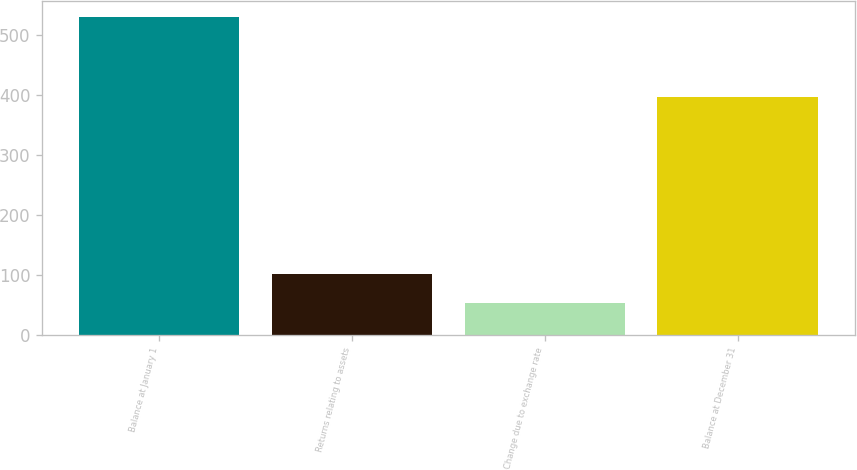<chart> <loc_0><loc_0><loc_500><loc_500><bar_chart><fcel>Balance at January 1<fcel>Returns relating to assets<fcel>Change due to exchange rate<fcel>Balance at December 31<nl><fcel>530<fcel>100.7<fcel>53<fcel>396<nl></chart> 